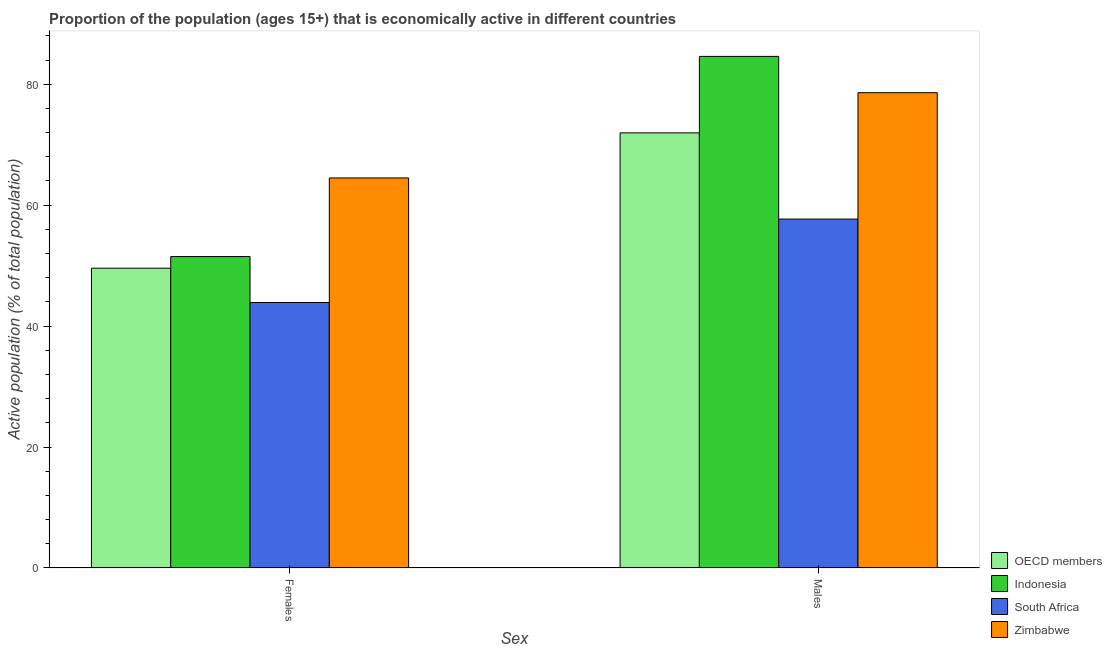How many bars are there on the 1st tick from the left?
Offer a very short reply. 4. What is the label of the 1st group of bars from the left?
Make the answer very short. Females. What is the percentage of economically active female population in OECD members?
Ensure brevity in your answer.  49.57. Across all countries, what is the maximum percentage of economically active male population?
Ensure brevity in your answer.  84.6. Across all countries, what is the minimum percentage of economically active female population?
Offer a terse response. 43.9. In which country was the percentage of economically active male population maximum?
Ensure brevity in your answer.  Indonesia. In which country was the percentage of economically active male population minimum?
Your response must be concise. South Africa. What is the total percentage of economically active male population in the graph?
Offer a terse response. 292.85. What is the difference between the percentage of economically active female population in South Africa and that in Zimbabwe?
Your answer should be compact. -20.6. What is the difference between the percentage of economically active male population in Zimbabwe and the percentage of economically active female population in Indonesia?
Give a very brief answer. 27.1. What is the average percentage of economically active female population per country?
Give a very brief answer. 52.37. What is the difference between the percentage of economically active male population and percentage of economically active female population in OECD members?
Offer a terse response. 22.38. What is the ratio of the percentage of economically active male population in South Africa to that in Indonesia?
Make the answer very short. 0.68. Is the percentage of economically active male population in OECD members less than that in Zimbabwe?
Make the answer very short. Yes. In how many countries, is the percentage of economically active female population greater than the average percentage of economically active female population taken over all countries?
Keep it short and to the point. 1. What does the 4th bar from the left in Males represents?
Ensure brevity in your answer.  Zimbabwe. What does the 1st bar from the right in Males represents?
Make the answer very short. Zimbabwe. How many bars are there?
Your answer should be very brief. 8. Are all the bars in the graph horizontal?
Offer a terse response. No. How many countries are there in the graph?
Offer a very short reply. 4. Are the values on the major ticks of Y-axis written in scientific E-notation?
Your answer should be very brief. No. How are the legend labels stacked?
Offer a very short reply. Vertical. What is the title of the graph?
Provide a succinct answer. Proportion of the population (ages 15+) that is economically active in different countries. Does "Antigua and Barbuda" appear as one of the legend labels in the graph?
Your answer should be very brief. No. What is the label or title of the X-axis?
Make the answer very short. Sex. What is the label or title of the Y-axis?
Your answer should be very brief. Active population (% of total population). What is the Active population (% of total population) in OECD members in Females?
Keep it short and to the point. 49.57. What is the Active population (% of total population) in Indonesia in Females?
Make the answer very short. 51.5. What is the Active population (% of total population) of South Africa in Females?
Give a very brief answer. 43.9. What is the Active population (% of total population) in Zimbabwe in Females?
Provide a short and direct response. 64.5. What is the Active population (% of total population) of OECD members in Males?
Provide a short and direct response. 71.95. What is the Active population (% of total population) of Indonesia in Males?
Your answer should be compact. 84.6. What is the Active population (% of total population) of South Africa in Males?
Your answer should be very brief. 57.7. What is the Active population (% of total population) in Zimbabwe in Males?
Your answer should be compact. 78.6. Across all Sex, what is the maximum Active population (% of total population) in OECD members?
Your answer should be compact. 71.95. Across all Sex, what is the maximum Active population (% of total population) of Indonesia?
Make the answer very short. 84.6. Across all Sex, what is the maximum Active population (% of total population) of South Africa?
Make the answer very short. 57.7. Across all Sex, what is the maximum Active population (% of total population) in Zimbabwe?
Offer a very short reply. 78.6. Across all Sex, what is the minimum Active population (% of total population) in OECD members?
Give a very brief answer. 49.57. Across all Sex, what is the minimum Active population (% of total population) of Indonesia?
Keep it short and to the point. 51.5. Across all Sex, what is the minimum Active population (% of total population) in South Africa?
Keep it short and to the point. 43.9. Across all Sex, what is the minimum Active population (% of total population) in Zimbabwe?
Provide a succinct answer. 64.5. What is the total Active population (% of total population) of OECD members in the graph?
Ensure brevity in your answer.  121.53. What is the total Active population (% of total population) in Indonesia in the graph?
Ensure brevity in your answer.  136.1. What is the total Active population (% of total population) in South Africa in the graph?
Your answer should be compact. 101.6. What is the total Active population (% of total population) in Zimbabwe in the graph?
Keep it short and to the point. 143.1. What is the difference between the Active population (% of total population) of OECD members in Females and that in Males?
Provide a succinct answer. -22.38. What is the difference between the Active population (% of total population) in Indonesia in Females and that in Males?
Keep it short and to the point. -33.1. What is the difference between the Active population (% of total population) of South Africa in Females and that in Males?
Ensure brevity in your answer.  -13.8. What is the difference between the Active population (% of total population) in Zimbabwe in Females and that in Males?
Ensure brevity in your answer.  -14.1. What is the difference between the Active population (% of total population) of OECD members in Females and the Active population (% of total population) of Indonesia in Males?
Your answer should be very brief. -35.03. What is the difference between the Active population (% of total population) of OECD members in Females and the Active population (% of total population) of South Africa in Males?
Give a very brief answer. -8.13. What is the difference between the Active population (% of total population) in OECD members in Females and the Active population (% of total population) in Zimbabwe in Males?
Offer a very short reply. -29.03. What is the difference between the Active population (% of total population) of Indonesia in Females and the Active population (% of total population) of Zimbabwe in Males?
Provide a succinct answer. -27.1. What is the difference between the Active population (% of total population) in South Africa in Females and the Active population (% of total population) in Zimbabwe in Males?
Keep it short and to the point. -34.7. What is the average Active population (% of total population) of OECD members per Sex?
Offer a terse response. 60.76. What is the average Active population (% of total population) of Indonesia per Sex?
Your response must be concise. 68.05. What is the average Active population (% of total population) of South Africa per Sex?
Offer a very short reply. 50.8. What is the average Active population (% of total population) in Zimbabwe per Sex?
Make the answer very short. 71.55. What is the difference between the Active population (% of total population) of OECD members and Active population (% of total population) of Indonesia in Females?
Provide a succinct answer. -1.93. What is the difference between the Active population (% of total population) in OECD members and Active population (% of total population) in South Africa in Females?
Keep it short and to the point. 5.67. What is the difference between the Active population (% of total population) in OECD members and Active population (% of total population) in Zimbabwe in Females?
Keep it short and to the point. -14.93. What is the difference between the Active population (% of total population) of South Africa and Active population (% of total population) of Zimbabwe in Females?
Offer a terse response. -20.6. What is the difference between the Active population (% of total population) of OECD members and Active population (% of total population) of Indonesia in Males?
Provide a succinct answer. -12.65. What is the difference between the Active population (% of total population) in OECD members and Active population (% of total population) in South Africa in Males?
Offer a terse response. 14.25. What is the difference between the Active population (% of total population) in OECD members and Active population (% of total population) in Zimbabwe in Males?
Your answer should be very brief. -6.65. What is the difference between the Active population (% of total population) of Indonesia and Active population (% of total population) of South Africa in Males?
Provide a succinct answer. 26.9. What is the difference between the Active population (% of total population) of Indonesia and Active population (% of total population) of Zimbabwe in Males?
Your response must be concise. 6. What is the difference between the Active population (% of total population) of South Africa and Active population (% of total population) of Zimbabwe in Males?
Provide a succinct answer. -20.9. What is the ratio of the Active population (% of total population) in OECD members in Females to that in Males?
Provide a succinct answer. 0.69. What is the ratio of the Active population (% of total population) in Indonesia in Females to that in Males?
Offer a very short reply. 0.61. What is the ratio of the Active population (% of total population) of South Africa in Females to that in Males?
Your answer should be compact. 0.76. What is the ratio of the Active population (% of total population) in Zimbabwe in Females to that in Males?
Provide a succinct answer. 0.82. What is the difference between the highest and the second highest Active population (% of total population) in OECD members?
Keep it short and to the point. 22.38. What is the difference between the highest and the second highest Active population (% of total population) of Indonesia?
Offer a terse response. 33.1. What is the difference between the highest and the lowest Active population (% of total population) in OECD members?
Make the answer very short. 22.38. What is the difference between the highest and the lowest Active population (% of total population) of Indonesia?
Offer a terse response. 33.1. What is the difference between the highest and the lowest Active population (% of total population) in Zimbabwe?
Offer a terse response. 14.1. 